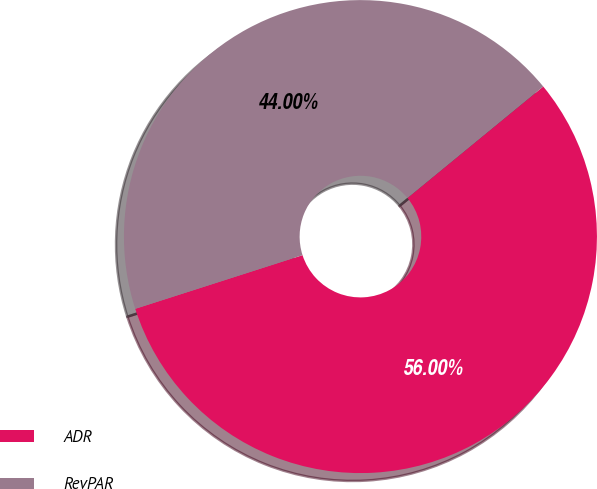Convert chart to OTSL. <chart><loc_0><loc_0><loc_500><loc_500><pie_chart><fcel>ADR<fcel>RevPAR<nl><fcel>56.0%<fcel>44.0%<nl></chart> 